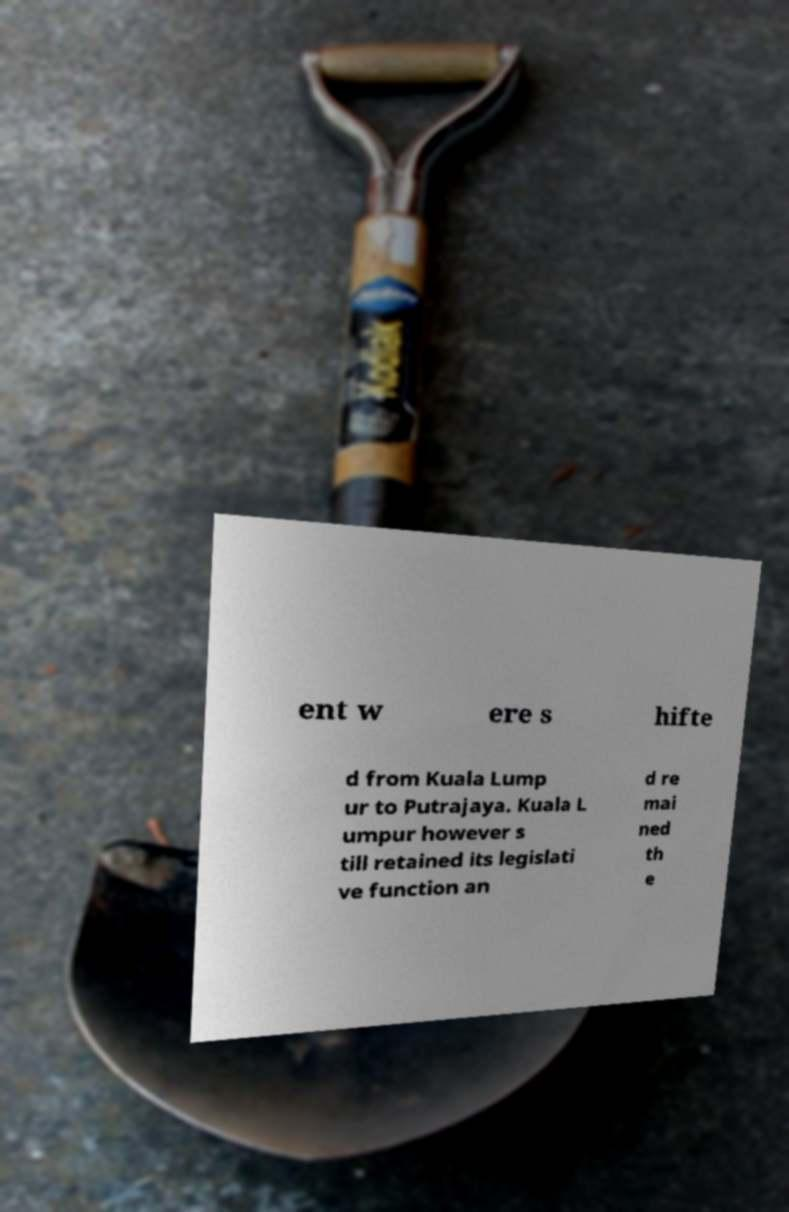For documentation purposes, I need the text within this image transcribed. Could you provide that? ent w ere s hifte d from Kuala Lump ur to Putrajaya. Kuala L umpur however s till retained its legislati ve function an d re mai ned th e 